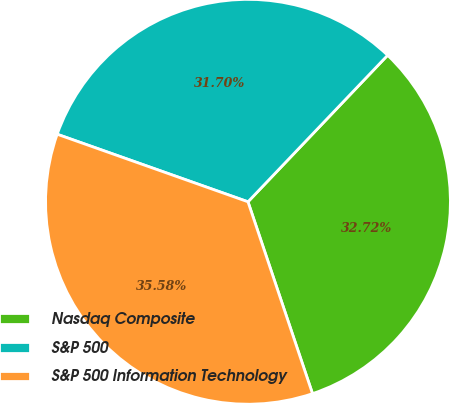<chart> <loc_0><loc_0><loc_500><loc_500><pie_chart><fcel>Nasdaq Composite<fcel>S&P 500<fcel>S&P 500 Information Technology<nl><fcel>32.72%<fcel>31.7%<fcel>35.58%<nl></chart> 